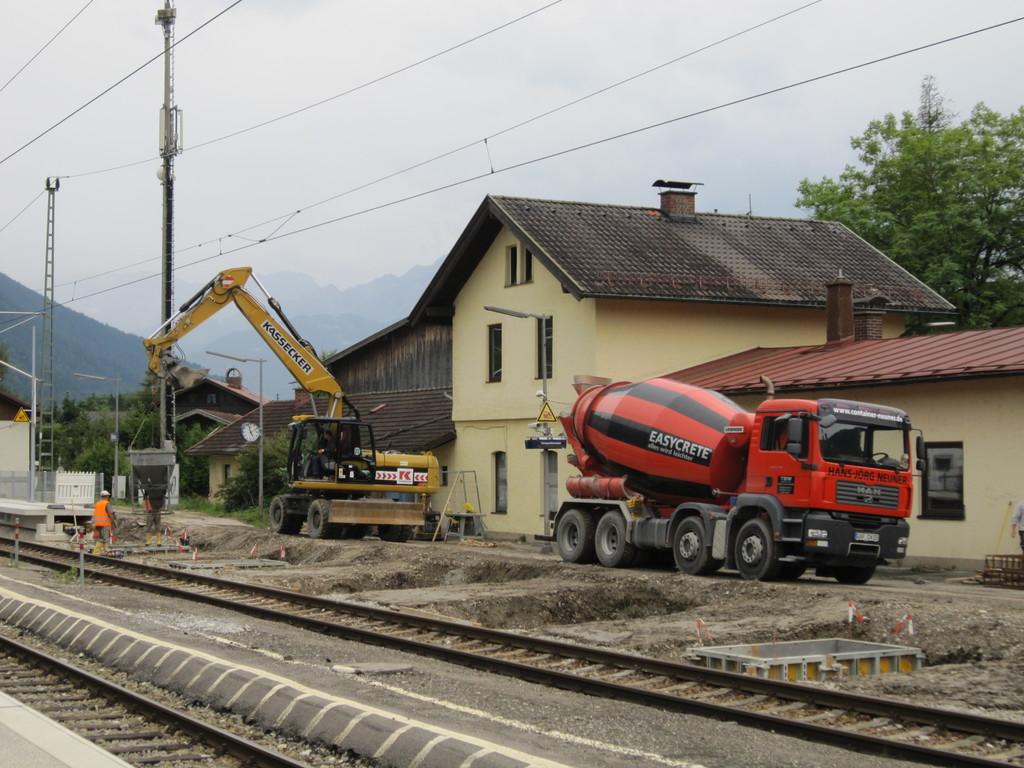What is the name on the concrete truck?
Ensure brevity in your answer.  Easycrete. What name is on the yellow arm?
Provide a succinct answer. Kassecker. 